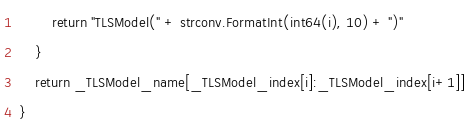Convert code to text. <code><loc_0><loc_0><loc_500><loc_500><_Go_>		return "TLSModel(" + strconv.FormatInt(int64(i), 10) + ")"
	}
	return _TLSModel_name[_TLSModel_index[i]:_TLSModel_index[i+1]]
}
</code> 